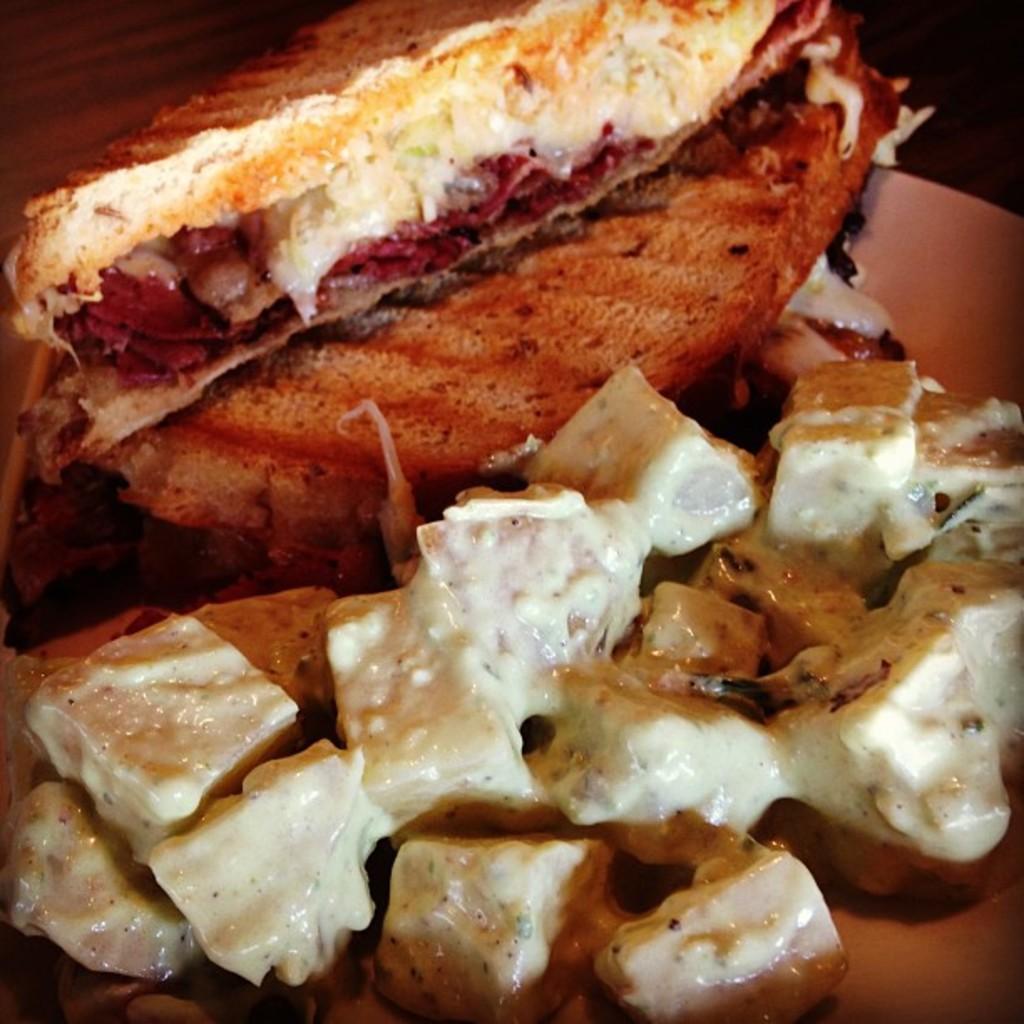Please provide a concise description of this image. In this image I can see the plate with food. It is on the surface. And there is a black background. 